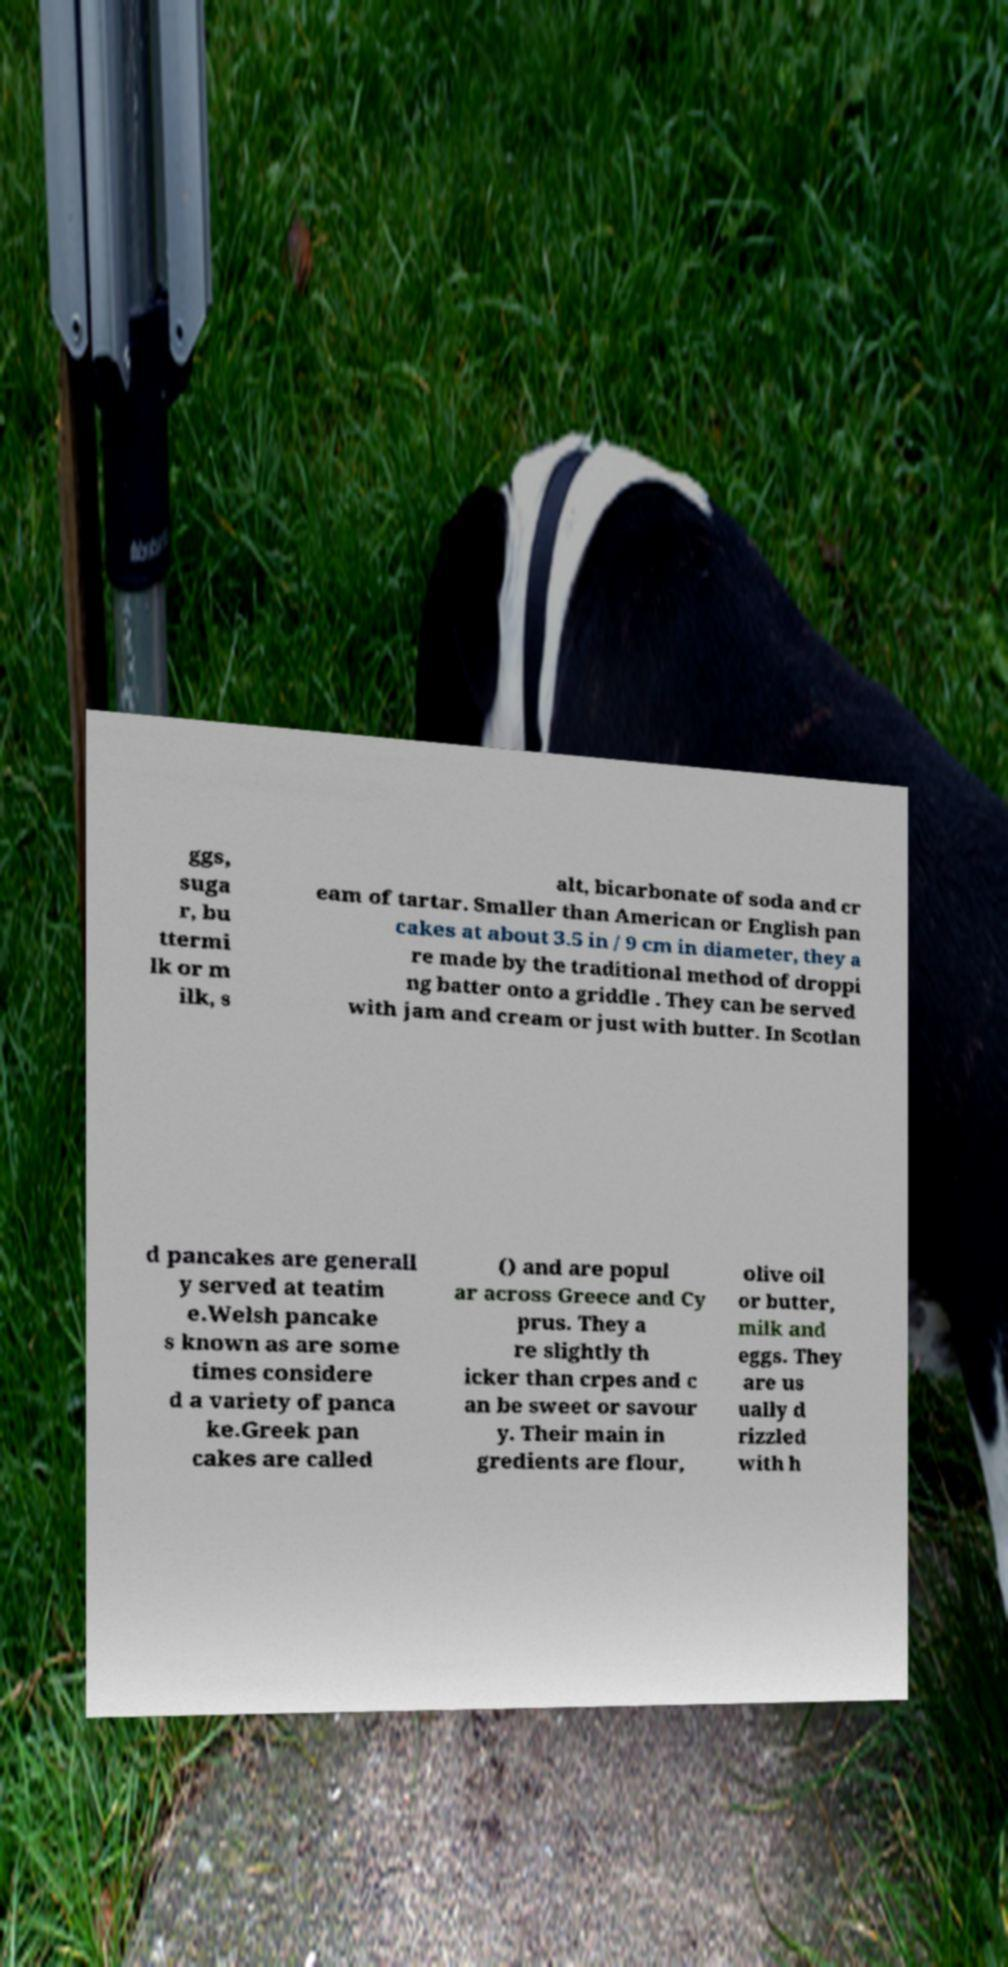Can you accurately transcribe the text from the provided image for me? ggs, suga r, bu ttermi lk or m ilk, s alt, bicarbonate of soda and cr eam of tartar. Smaller than American or English pan cakes at about 3.5 in / 9 cm in diameter, they a re made by the traditional method of droppi ng batter onto a griddle . They can be served with jam and cream or just with butter. In Scotlan d pancakes are generall y served at teatim e.Welsh pancake s known as are some times considere d a variety of panca ke.Greek pan cakes are called () and are popul ar across Greece and Cy prus. They a re slightly th icker than crpes and c an be sweet or savour y. Their main in gredients are flour, olive oil or butter, milk and eggs. They are us ually d rizzled with h 